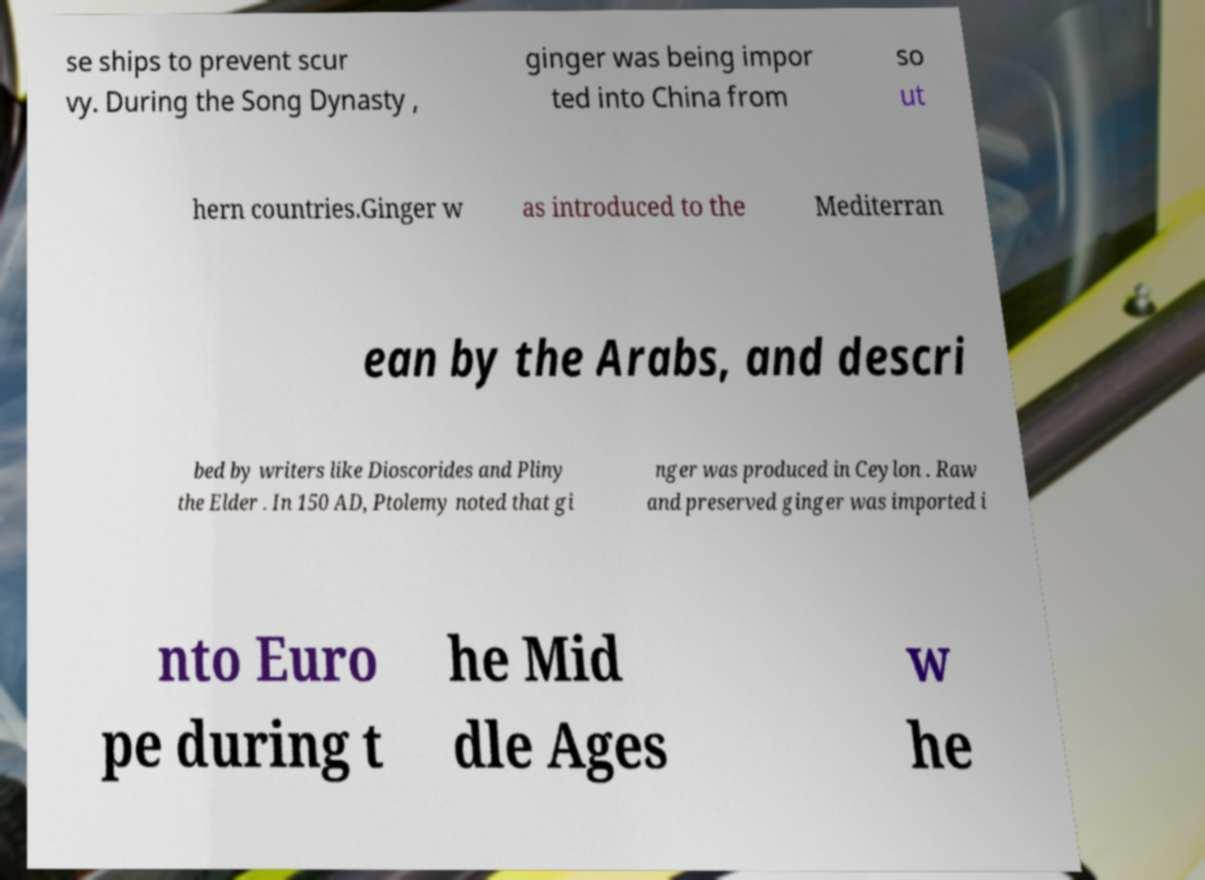I need the written content from this picture converted into text. Can you do that? se ships to prevent scur vy. During the Song Dynasty , ginger was being impor ted into China from so ut hern countries.Ginger w as introduced to the Mediterran ean by the Arabs, and descri bed by writers like Dioscorides and Pliny the Elder . In 150 AD, Ptolemy noted that gi nger was produced in Ceylon . Raw and preserved ginger was imported i nto Euro pe during t he Mid dle Ages w he 